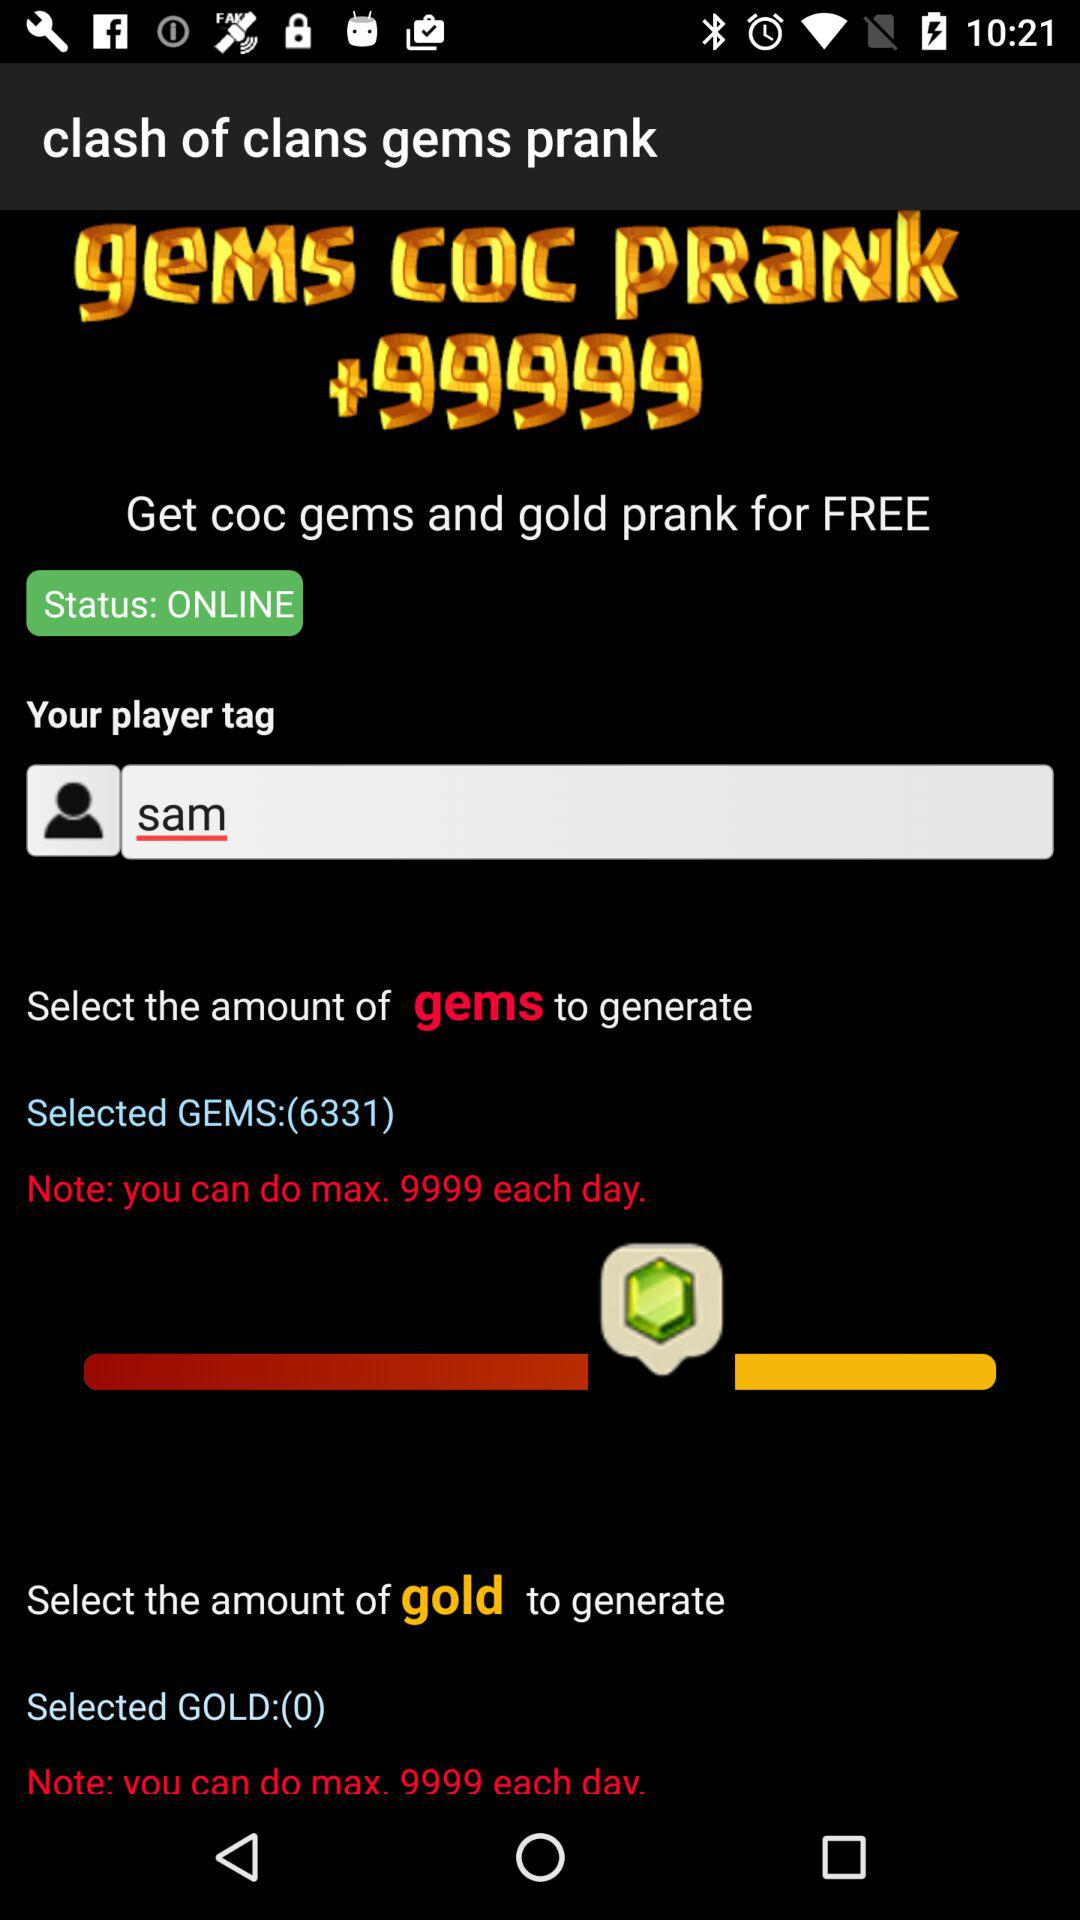What is the selected number of gems? The selected number of gems is 6331. 